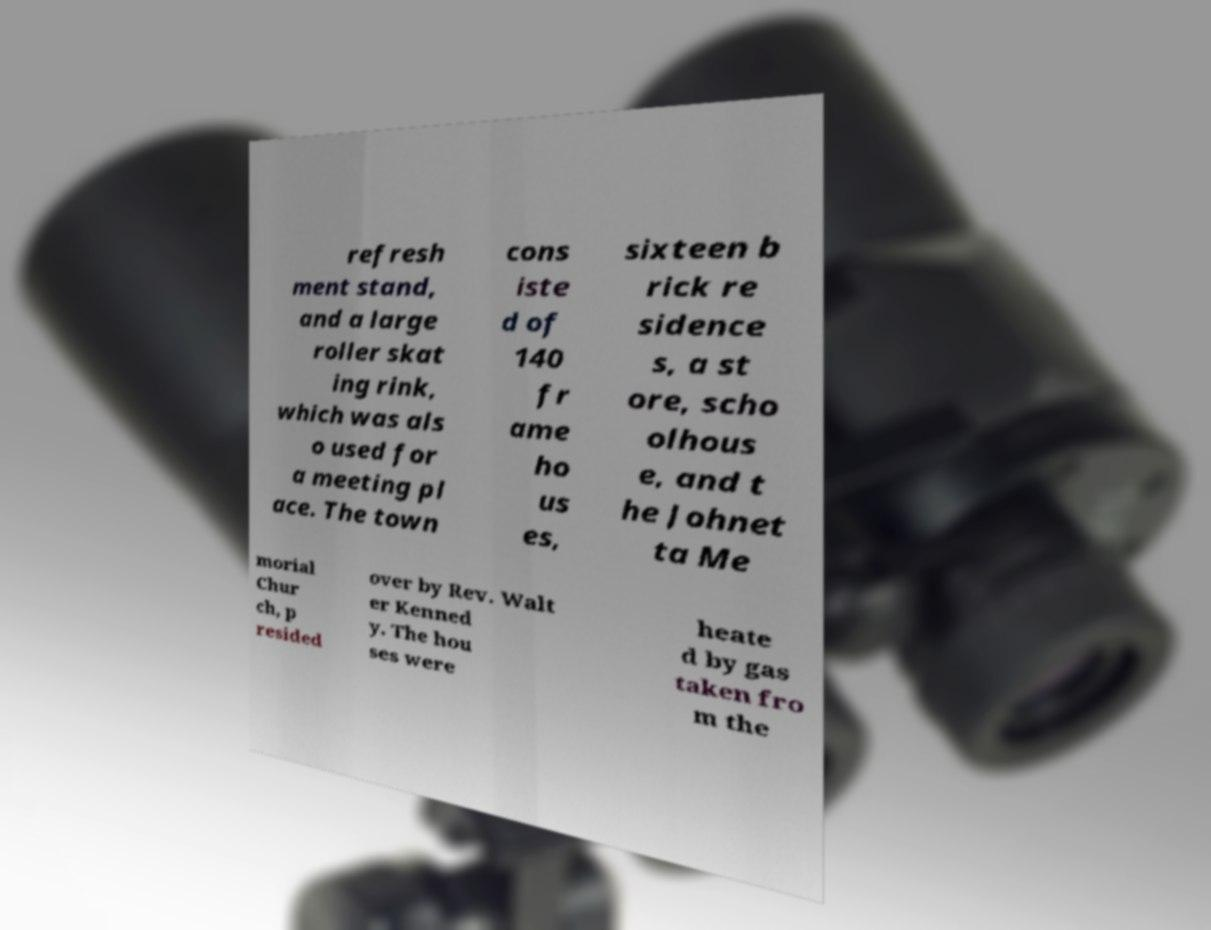Could you extract and type out the text from this image? refresh ment stand, and a large roller skat ing rink, which was als o used for a meeting pl ace. The town cons iste d of 140 fr ame ho us es, sixteen b rick re sidence s, a st ore, scho olhous e, and t he Johnet ta Me morial Chur ch, p resided over by Rev. Walt er Kenned y. The hou ses were heate d by gas taken fro m the 